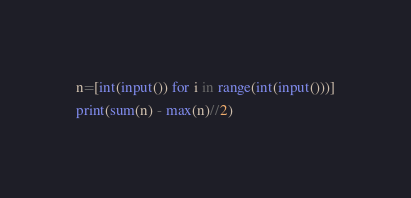<code> <loc_0><loc_0><loc_500><loc_500><_Python_>n=[int(input()) for i in range(int(input()))]
print(sum(n) - max(n)//2)</code> 